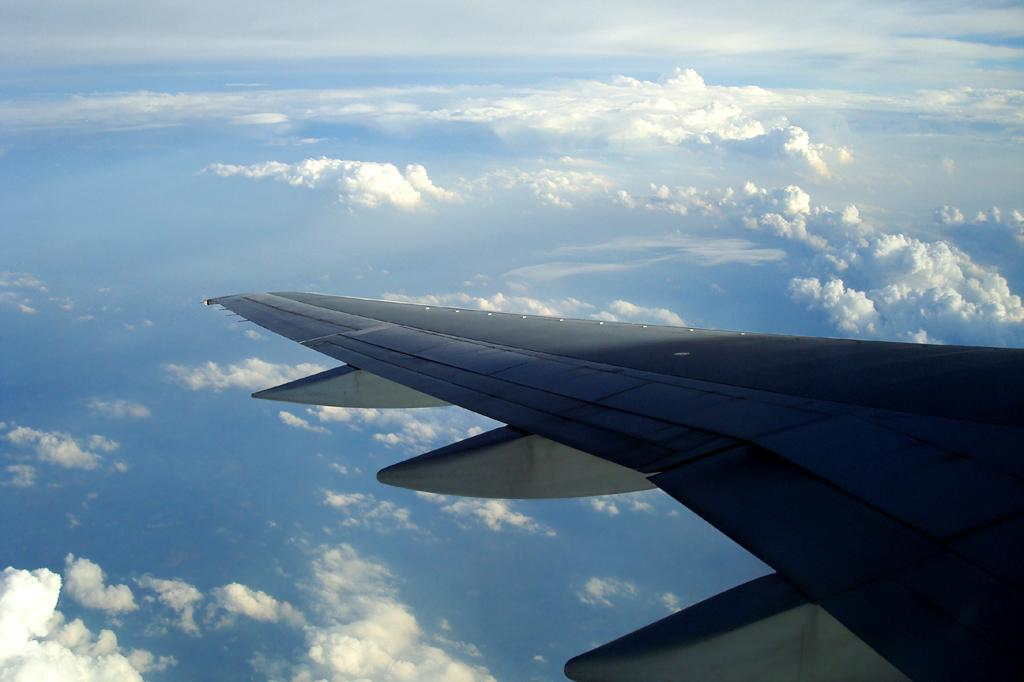What is the main subject of the picture? The main subject of the picture is an airplane. What can be seen in the background of the image? The sky is white and blue in color. What part of the train can be seen in the image? There is no train present in the image; it features an airplane. What type of conversation is happening between the passengers in the image? There are no passengers or conversation visible in the image. 